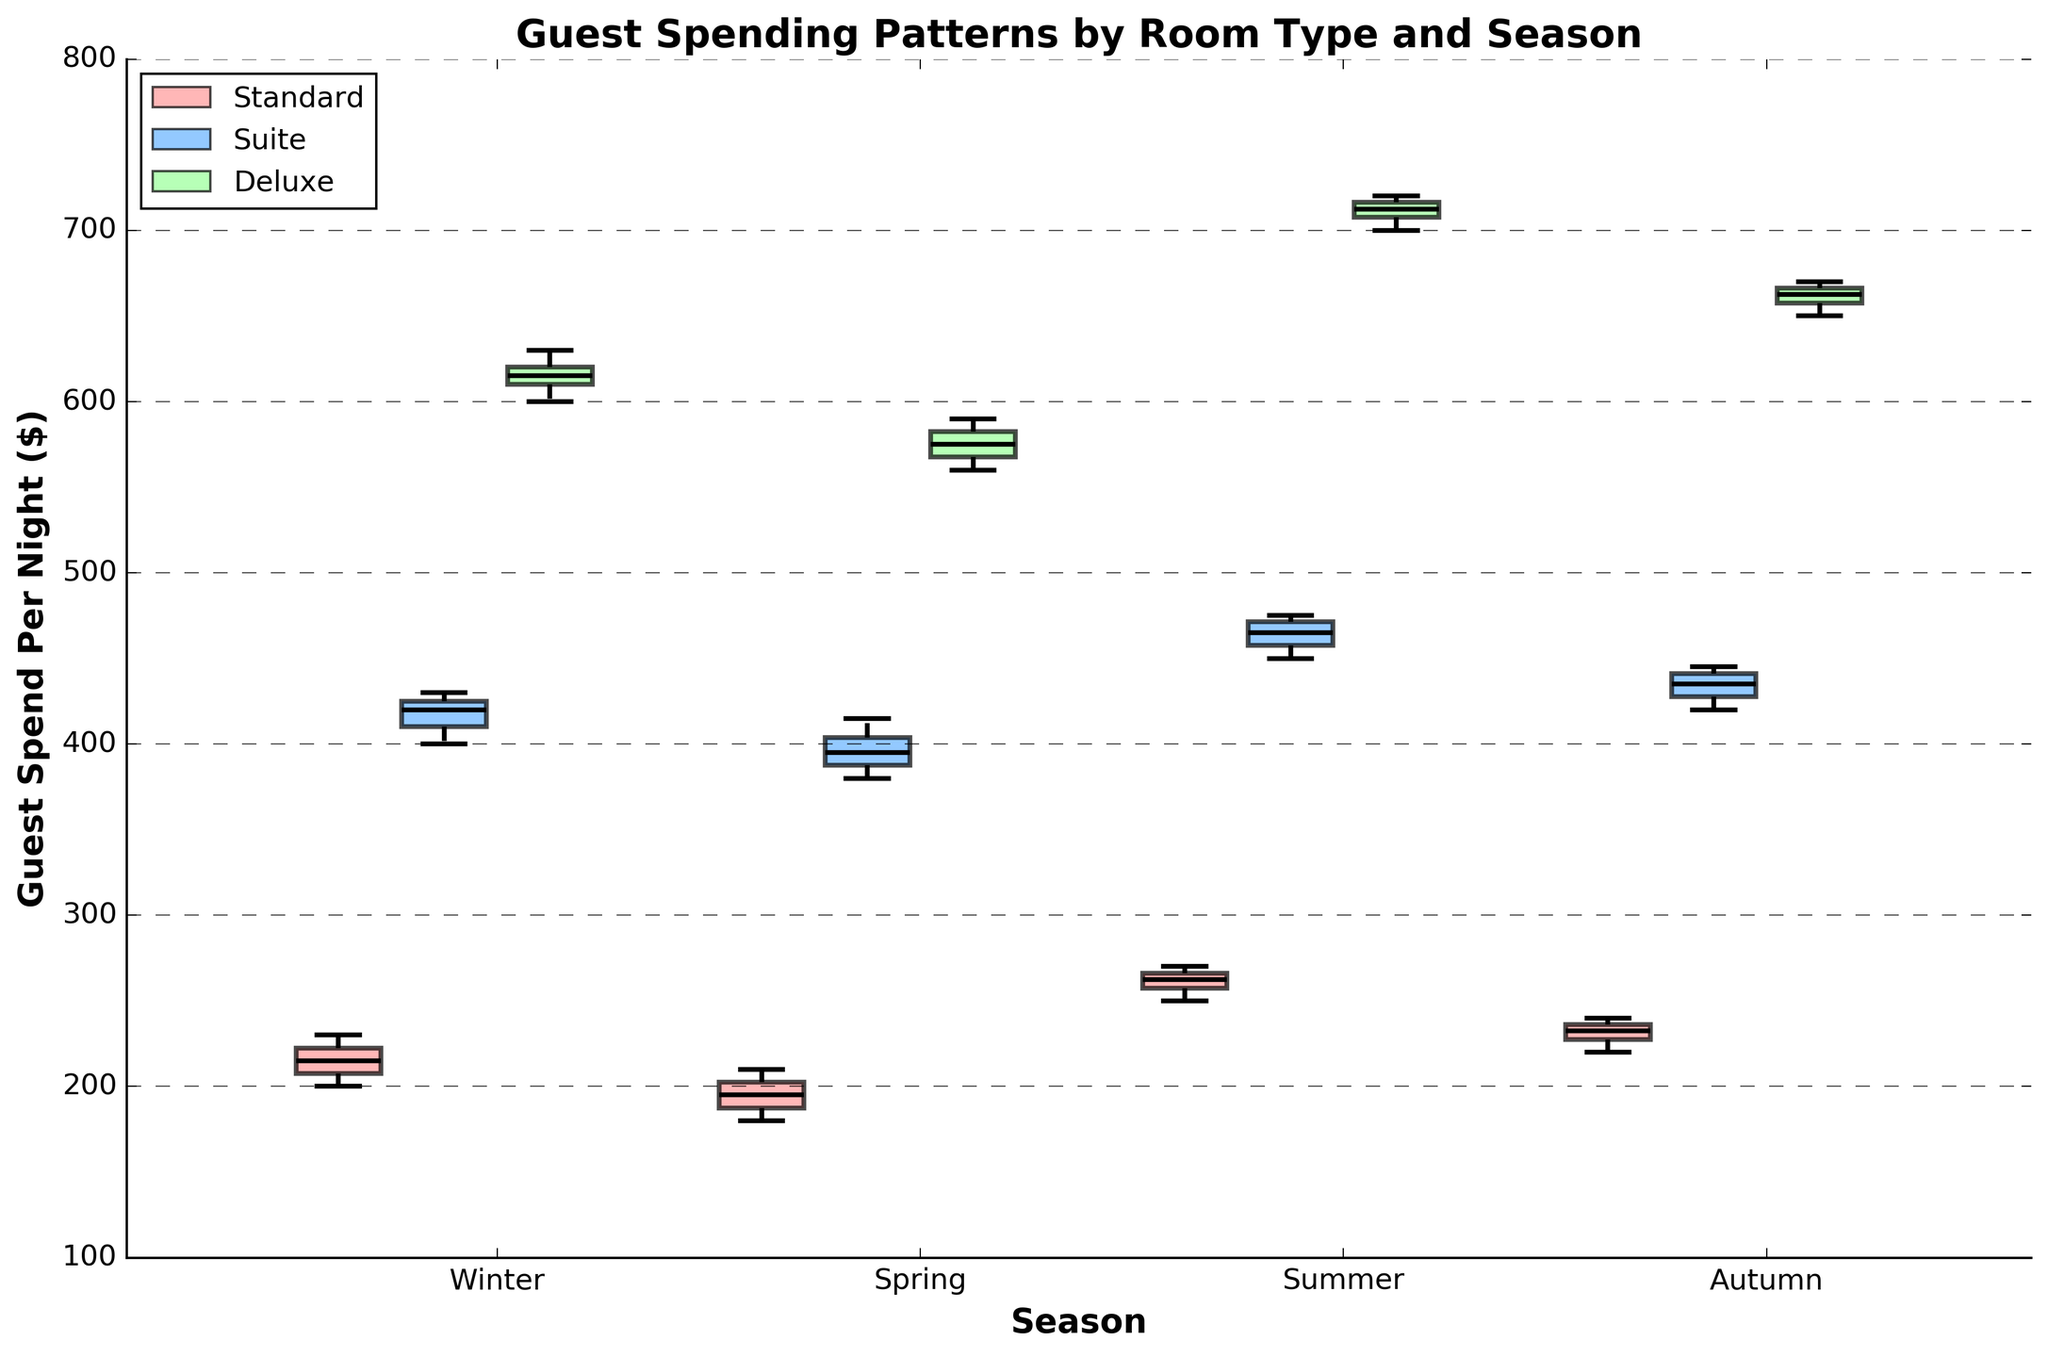How are the seasons represented in the plot? The x-axis of the plot represents the seasons (Winter, Spring, Summer, Autumn). Each season is labeled on the x-axis, making it easy to identify the data distribution for each.
Answer: Winter, Spring, Summer, Autumn What's the title of the figure? The title of the figure is displayed at the top above the plot. The title reads, "Guest Spending Patterns by Room Type and Season."
Answer: Guest Spending Patterns by Room Type and Season Which room type has the highest median spending in Winter? To find the room type with the highest median spending in Winter, observe the box plots for Winter and compare the median lines inside each box. The Deluxe room type has the highest median spending in Winter.
Answer: Deluxe What is the range of guest spending for Standard rooms in Summer? The range of guest spending can be determined by the distance between the bottom and top whiskers of the Standard room type box plot in Summer. The lowest value is 250, and the highest is 270.
Answer: 250 to 270 Which season shows the highest variability in guest spending for Suite rooms? Variability in spending can be seen through the height of the box and length of the whiskers. For Suite rooms, Winter has the widest range, indicating the highest variability.
Answer: Winter Which room type shows the least variability in guest spending in Autumn? To find the least variability, look for the shortest box and whiskers. For Autumn, the Standard room type has the least variability, seen by the narrowest box and shorter whiskers.
Answer: Standard Compare the median spending for Deluxe rooms between Spring and Autumn. Which is higher? The medians are represented by the line inside each box plot. Compare the Deluxe room type medians for Spring and Autumn. The median for Deluxe in Autumn (660) is higher than in Spring (580).
Answer: Autumn What does the width of each box represent in the plot? In a Variable Width Box Plot, the width of each box represents the number of data points or the sample size within that category. Wider boxes have more data points and vice versa.
Answer: Number of data points What is the difference in median spending between Suite and Standard rooms in Summer? Identify the median lines for Suite and Standard rooms in Summer. The median for Suite is 460, and for Standard, it's 265. The difference is 460 - 265.
Answer: 195 During which season is guest spending for Standard rooms the lowest, and what is this value? By comparing the minimum whisker values for Standard rooms across all seasons, it's apparent that Spring has the lowest value at 180.
Answer: Spring, 180 